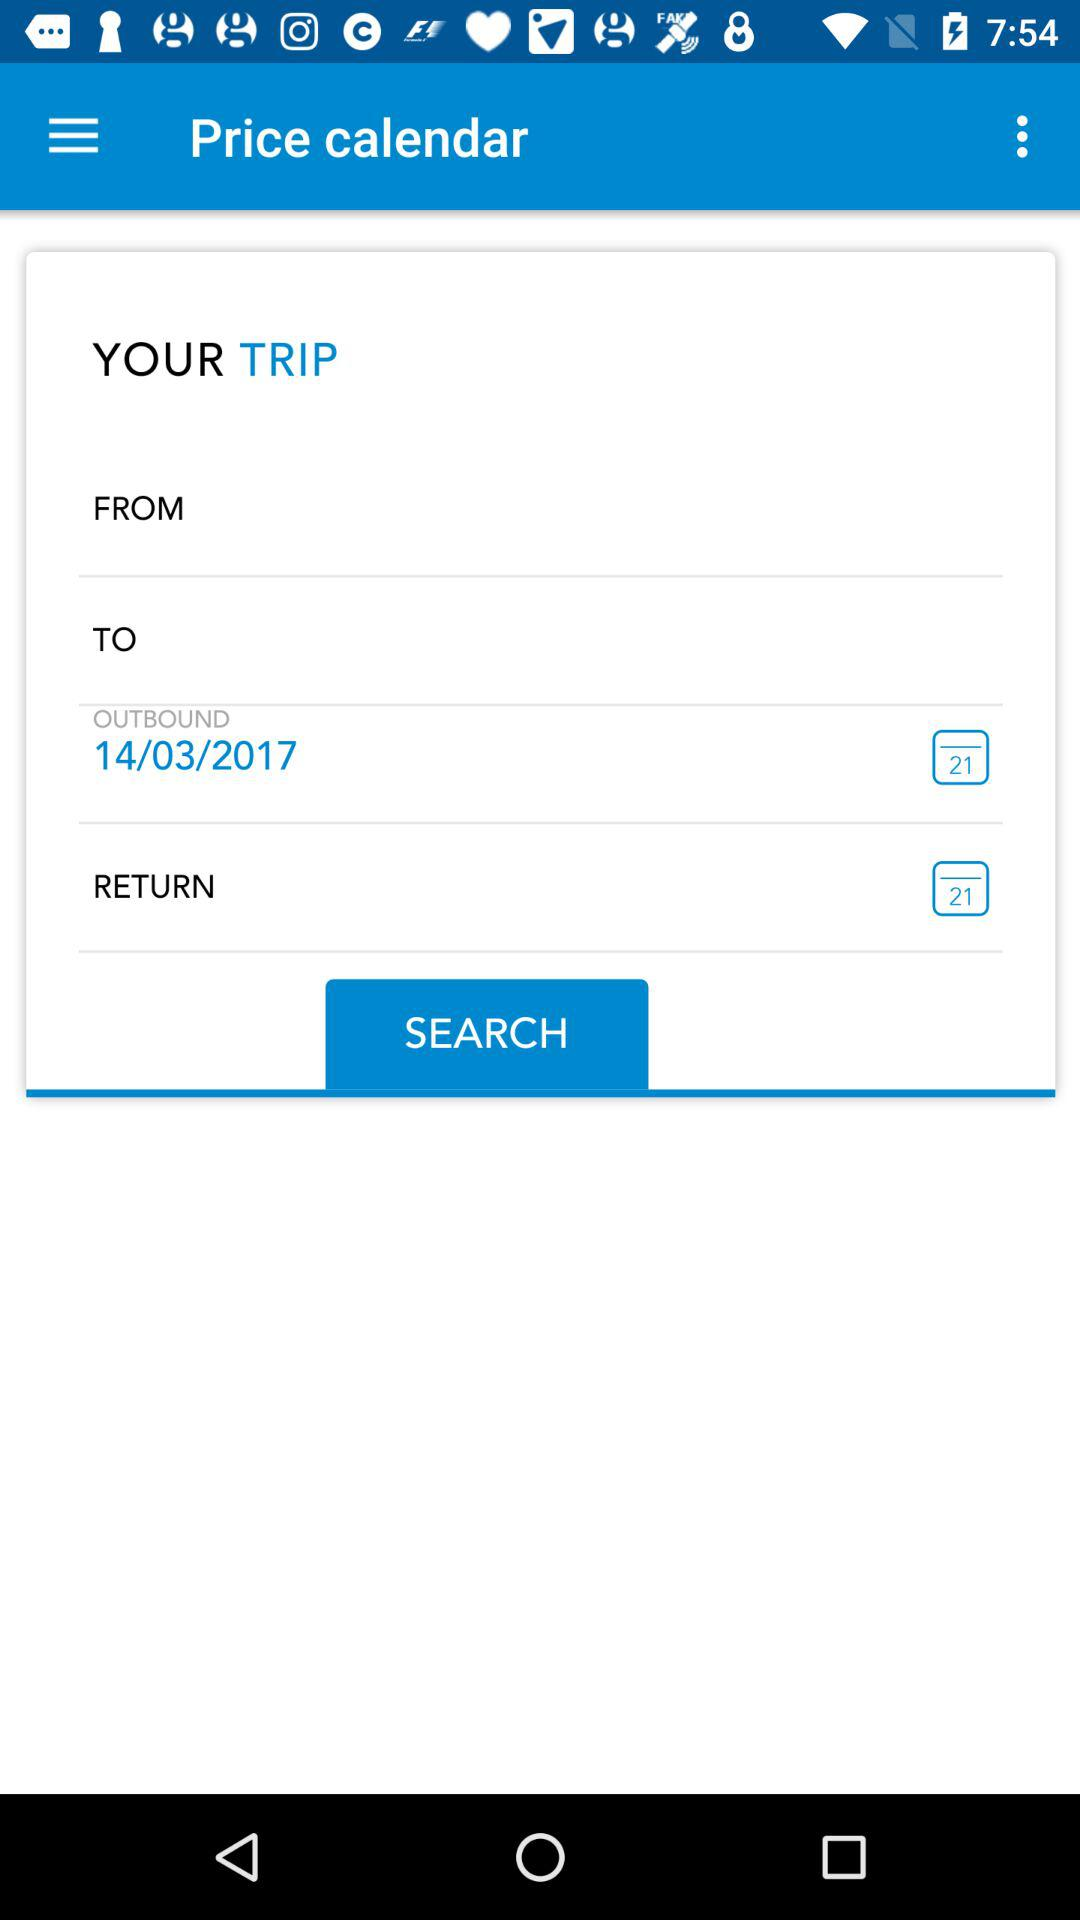What is the return date?
When the provided information is insufficient, respond with <no answer>. <no answer> 